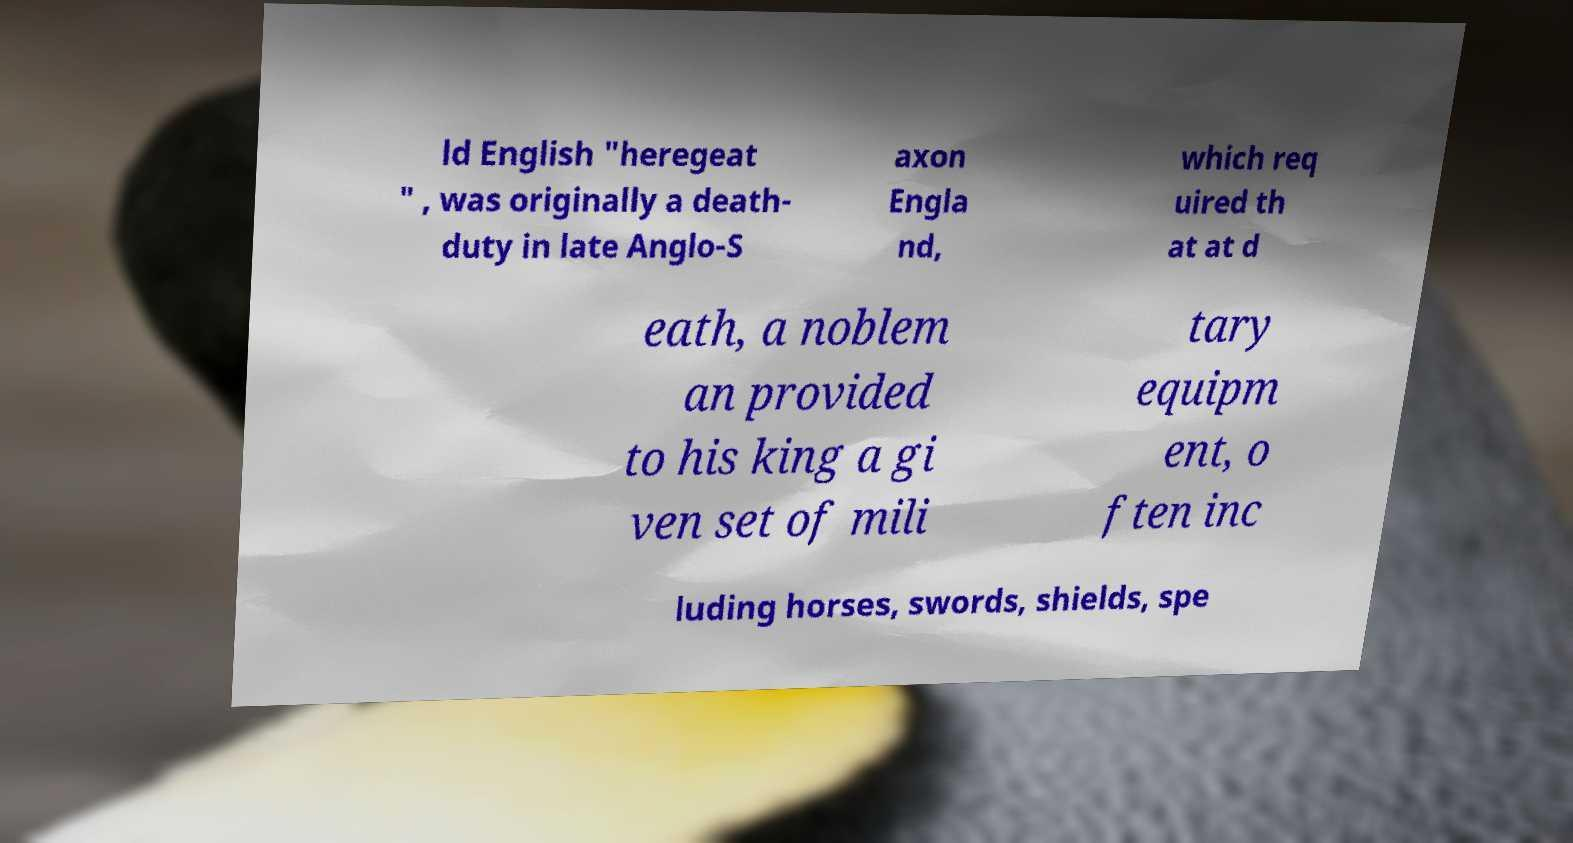Please identify and transcribe the text found in this image. ld English "heregeat " , was originally a death- duty in late Anglo-S axon Engla nd, which req uired th at at d eath, a noblem an provided to his king a gi ven set of mili tary equipm ent, o ften inc luding horses, swords, shields, spe 